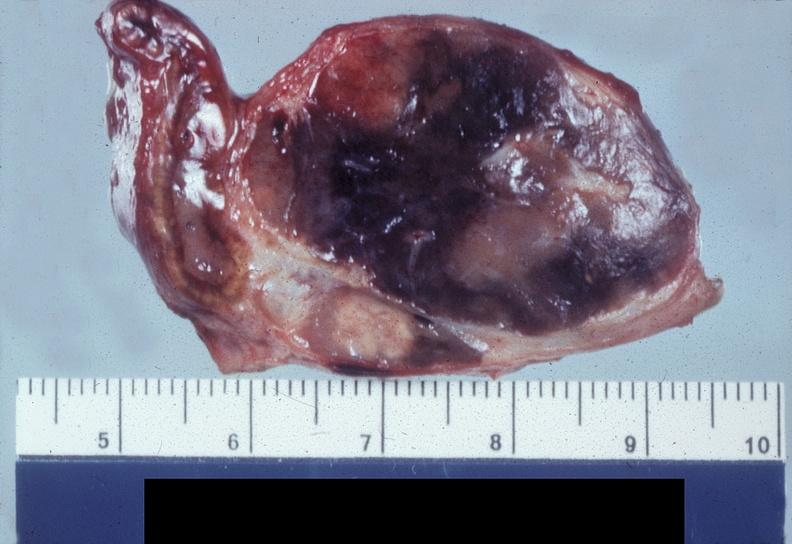where does this belong to?
Answer the question using a single word or phrase. Endocrine system 